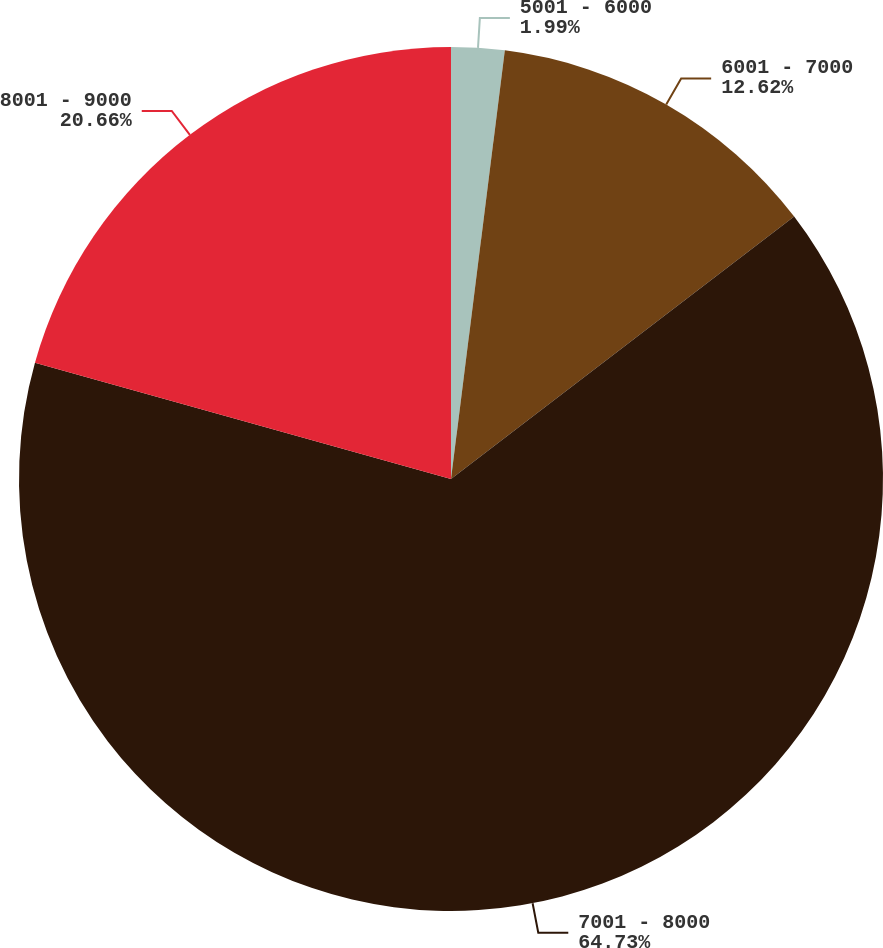Convert chart. <chart><loc_0><loc_0><loc_500><loc_500><pie_chart><fcel>5001 - 6000<fcel>6001 - 7000<fcel>7001 - 8000<fcel>8001 - 9000<nl><fcel>1.99%<fcel>12.62%<fcel>64.73%<fcel>20.66%<nl></chart> 